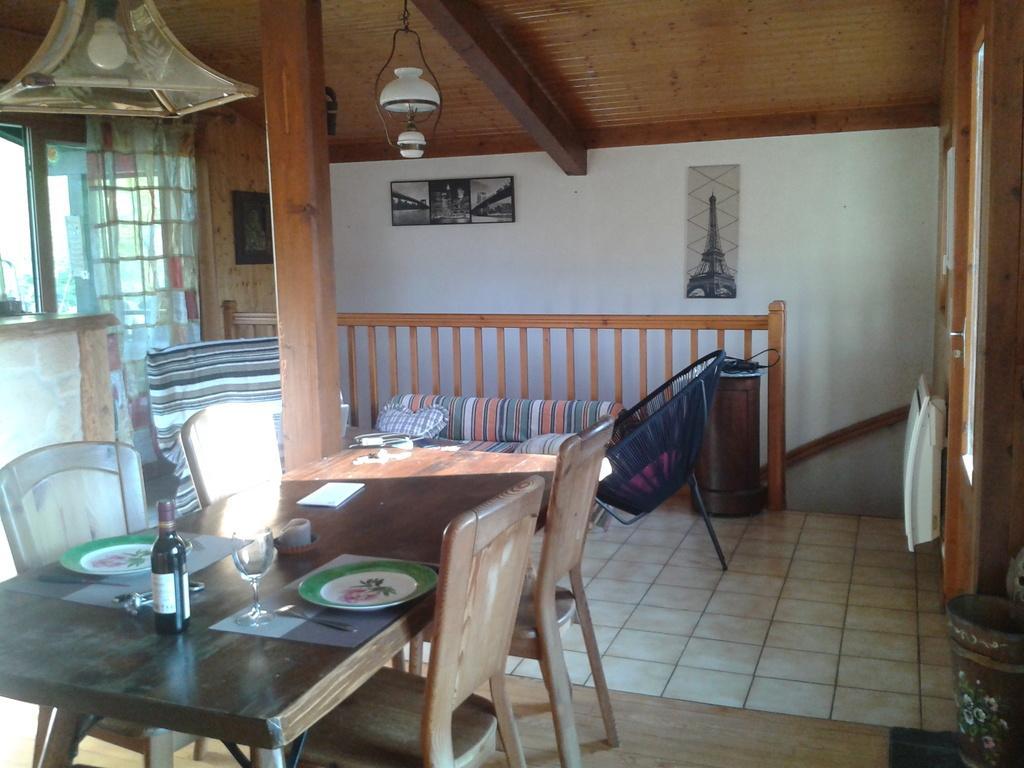In one or two sentences, can you explain what this image depicts? In this image, at the left side there is a table and there are some chairs, on that table there are some plates and there is a black color bottle, there is a glass, there is a black color chair, at the right side there is a white color object, at the top there is a shed, at the background there is a white color wall. 